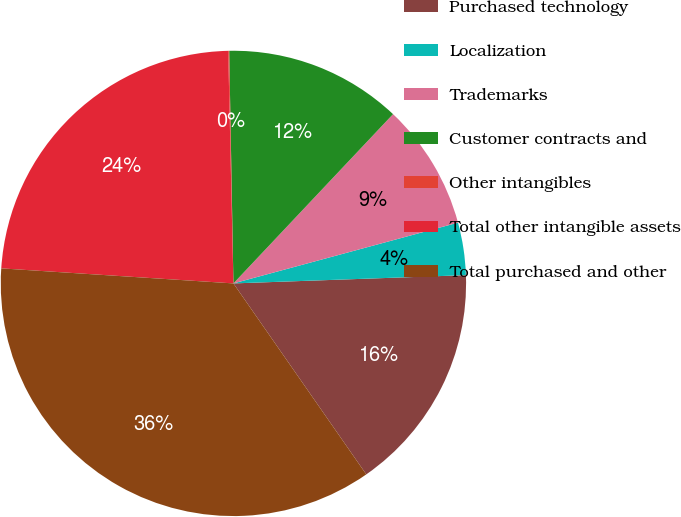Convert chart. <chart><loc_0><loc_0><loc_500><loc_500><pie_chart><fcel>Purchased technology<fcel>Localization<fcel>Trademarks<fcel>Customer contracts and<fcel>Other intangibles<fcel>Total other intangible assets<fcel>Total purchased and other<nl><fcel>15.89%<fcel>3.64%<fcel>8.76%<fcel>12.32%<fcel>0.07%<fcel>23.61%<fcel>35.7%<nl></chart> 